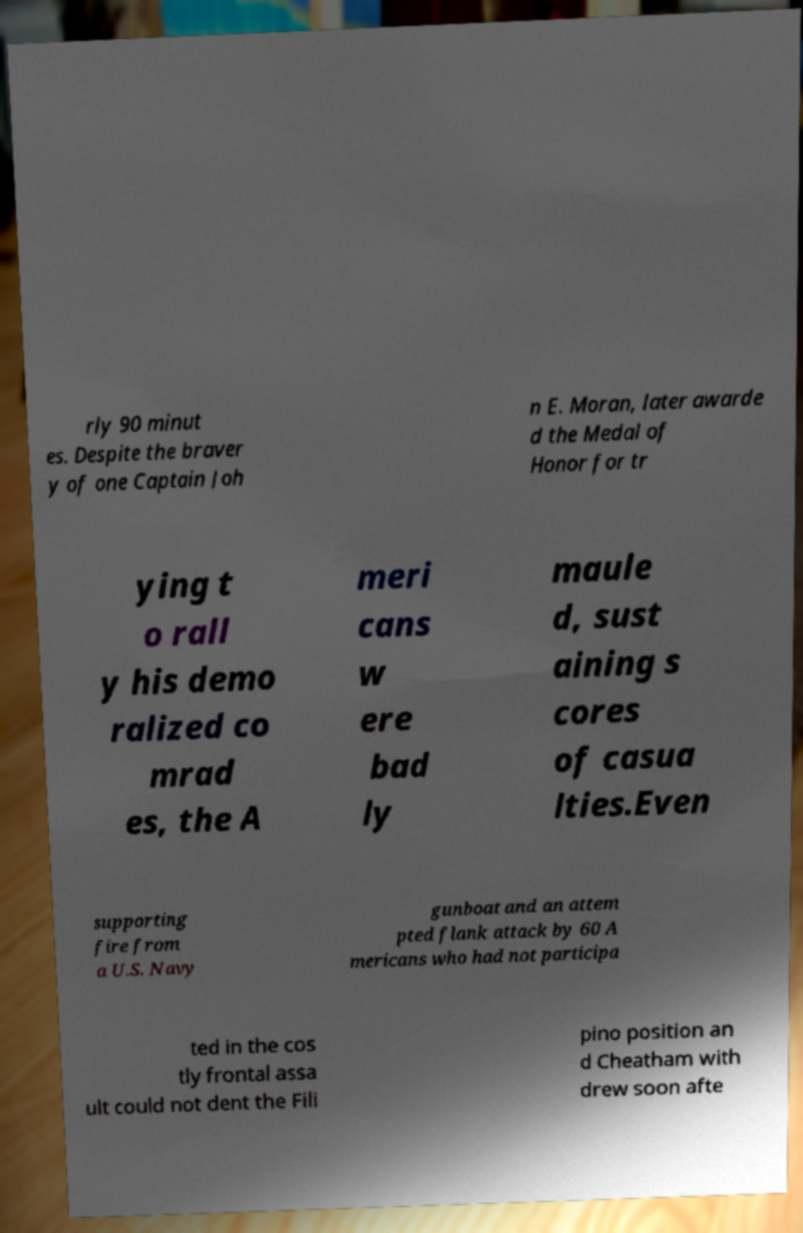Can you read and provide the text displayed in the image?This photo seems to have some interesting text. Can you extract and type it out for me? rly 90 minut es. Despite the braver y of one Captain Joh n E. Moran, later awarde d the Medal of Honor for tr ying t o rall y his demo ralized co mrad es, the A meri cans w ere bad ly maule d, sust aining s cores of casua lties.Even supporting fire from a U.S. Navy gunboat and an attem pted flank attack by 60 A mericans who had not participa ted in the cos tly frontal assa ult could not dent the Fili pino position an d Cheatham with drew soon afte 